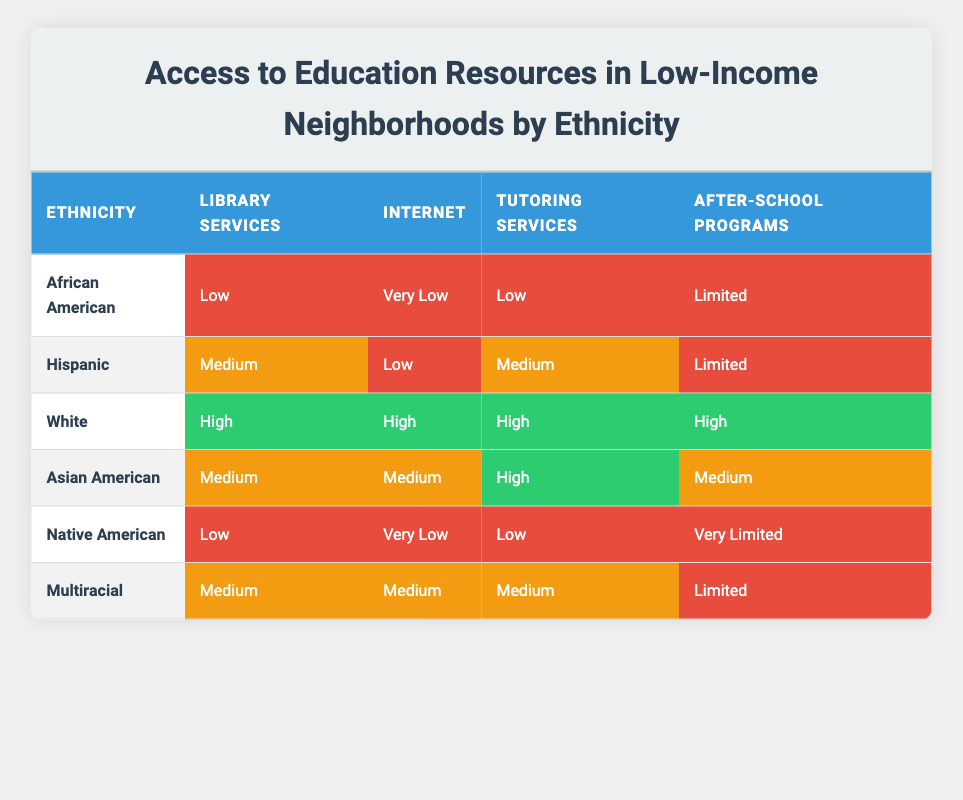What is the access level to library services for Native American communities? According to the table, Native American communities have "Low" access to library services.
Answer: Low Which ethnicity has the highest access to internet services? The table shows that White communities have "High" access to internet services, which is higher than any other ethnicity listed.
Answer: High Is it true that Hispanic communities have limited access to after-school programs? Yes, the table indicates that Hispanic communities have "Limited" access to after-school programs, confirming the statement is true.
Answer: Yes What percentage of the ethnicities listed have low access to tutoring services? There are 6 ethnicities total, and out of these, African American, Native American, and Hispanic communities represent 3 out of 6 that have "Low" or "Medium" access to tutoring services. The exact percentage for low is (3/6)*100 = 50%.
Answer: 50% Which group has the lowest access to both library and internet services? By examining the table, African American and Native American groups both have "Low" to "Very Low" access to library and internet services, respectively, but Native American has "Very Low" for internet services, making it the lowest.
Answer: Native American If we averaged the access levels to after-school programs across all ethnicities, what would it be? The access levels are: Limited, Limited, High, Medium, Very Limited, Limited. Assigning numerical values (Very Limited = 1, Low = 2, Medium = 3, High = 4) gives (2+2+4+3+1+2)/6 = 2.33, which corresponds to between Limited and Medium access.
Answer: Between Limited and Medium How many ethnicities have high access to tutoring services? Looking at the table, only White and Asian American communities have "High" access to tutoring services, making it 2 ethnicities.
Answer: 2 Is access to library services consistently high across all ethnicities? No, the table clearly shows variability: African American and Native American have "Low" access, while White has "High," indicating inconsistency in library access.
Answer: No Which ethnic group has the best overall access to educational resources? The table indicates that the White ethnic group has "High" access across all categories of educational resources, making it the best overall.
Answer: White 